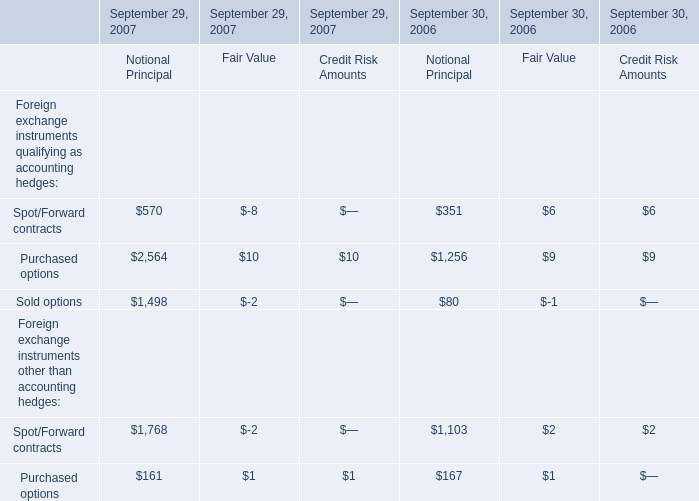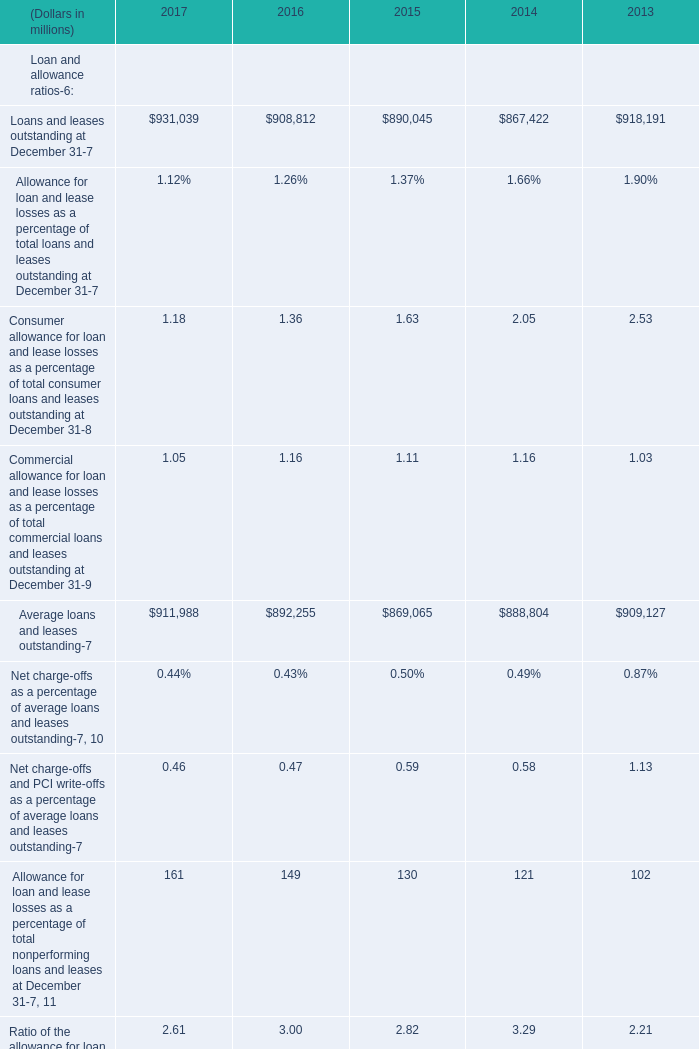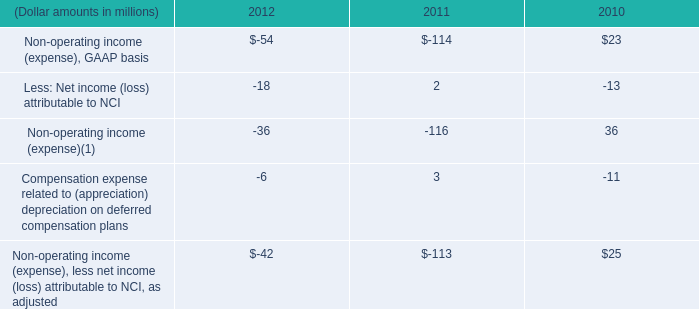What's the difference of average loans and leases between 2016 and 2017? (in million) 
Computations: (911988 - 892255)
Answer: 19733.0. 